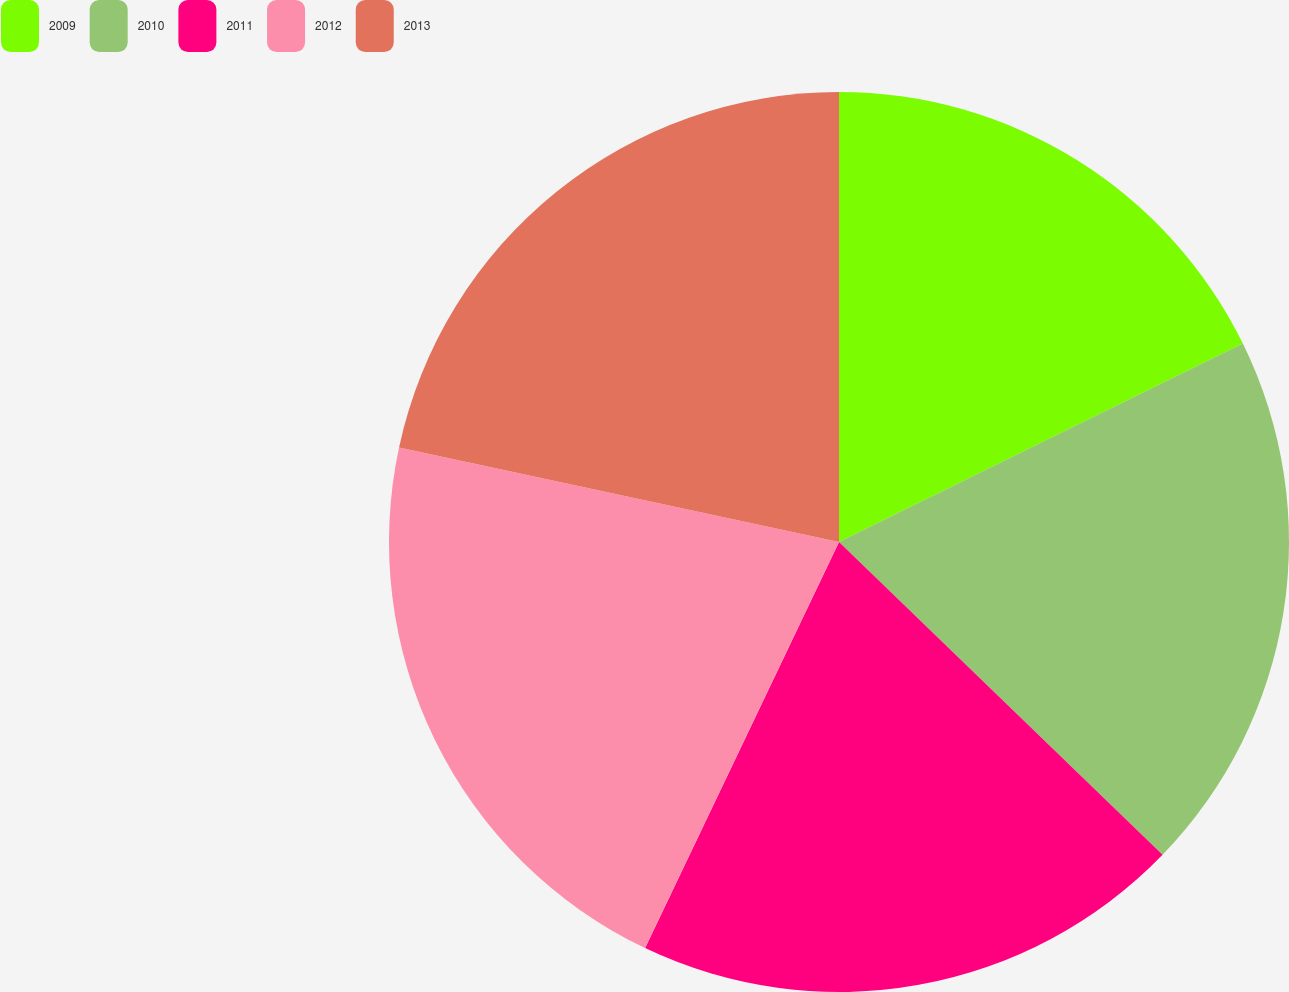Convert chart to OTSL. <chart><loc_0><loc_0><loc_500><loc_500><pie_chart><fcel>2009<fcel>2010<fcel>2011<fcel>2012<fcel>2013<nl><fcel>17.73%<fcel>19.5%<fcel>19.86%<fcel>21.28%<fcel>21.63%<nl></chart> 